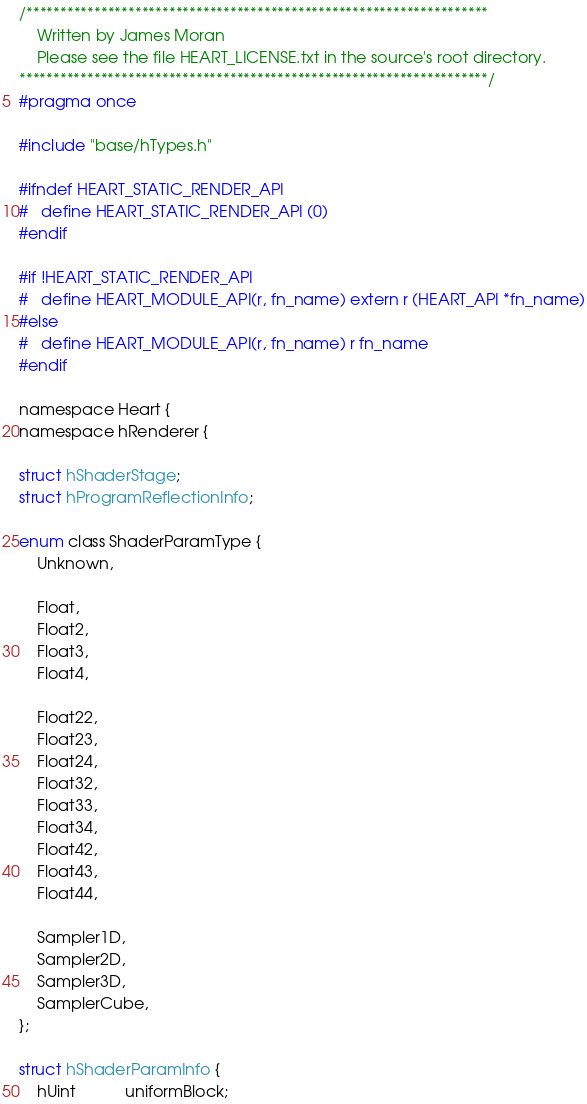Convert code to text. <code><loc_0><loc_0><loc_500><loc_500><_C_>/********************************************************************
    Written by James Moran
    Please see the file HEART_LICENSE.txt in the source's root directory.
*********************************************************************/
#pragma once

#include "base/hTypes.h"

#ifndef HEART_STATIC_RENDER_API
#   define HEART_STATIC_RENDER_API (0)
#endif

#if !HEART_STATIC_RENDER_API
#   define HEART_MODULE_API(r, fn_name) extern r (HEART_API *fn_name)
#else
#   define HEART_MODULE_API(r, fn_name) r fn_name
#endif

namespace Heart {
namespace hRenderer {

struct hShaderStage;
struct hProgramReflectionInfo;

enum class ShaderParamType {
    Unknown,

    Float,
    Float2,
    Float3,
    Float4,

    Float22,
    Float23,
    Float24,
    Float32,
    Float33,
    Float34,
    Float42,
    Float43,
    Float44,

    Sampler1D,
    Sampler2D,
    Sampler3D,
    SamplerCube,
};

struct hShaderParamInfo {
    hUint           uniformBlock;</code> 